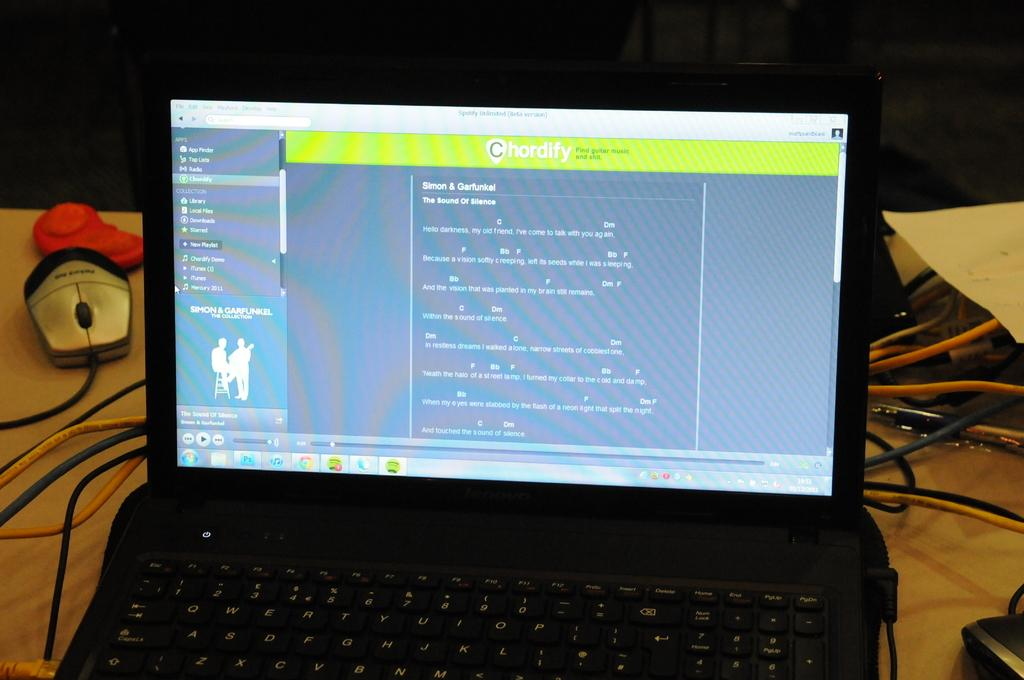<image>
Provide a brief description of the given image. a chordify web site being displayed on a laptop 